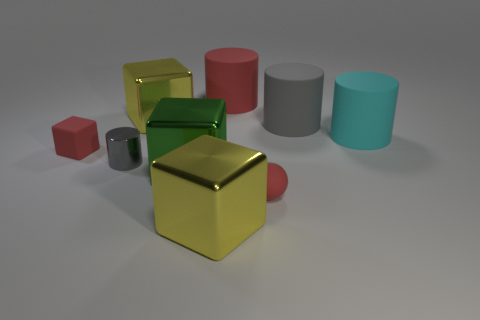Is the color of the rubber cube the same as the rubber sphere? Yes, the color of the rubber cube and the rubber sphere appears to be the same. Both objects exhibit a hue that closely resembles a shade of red, suggesting that the material's coloration is consistent across different shapes. 